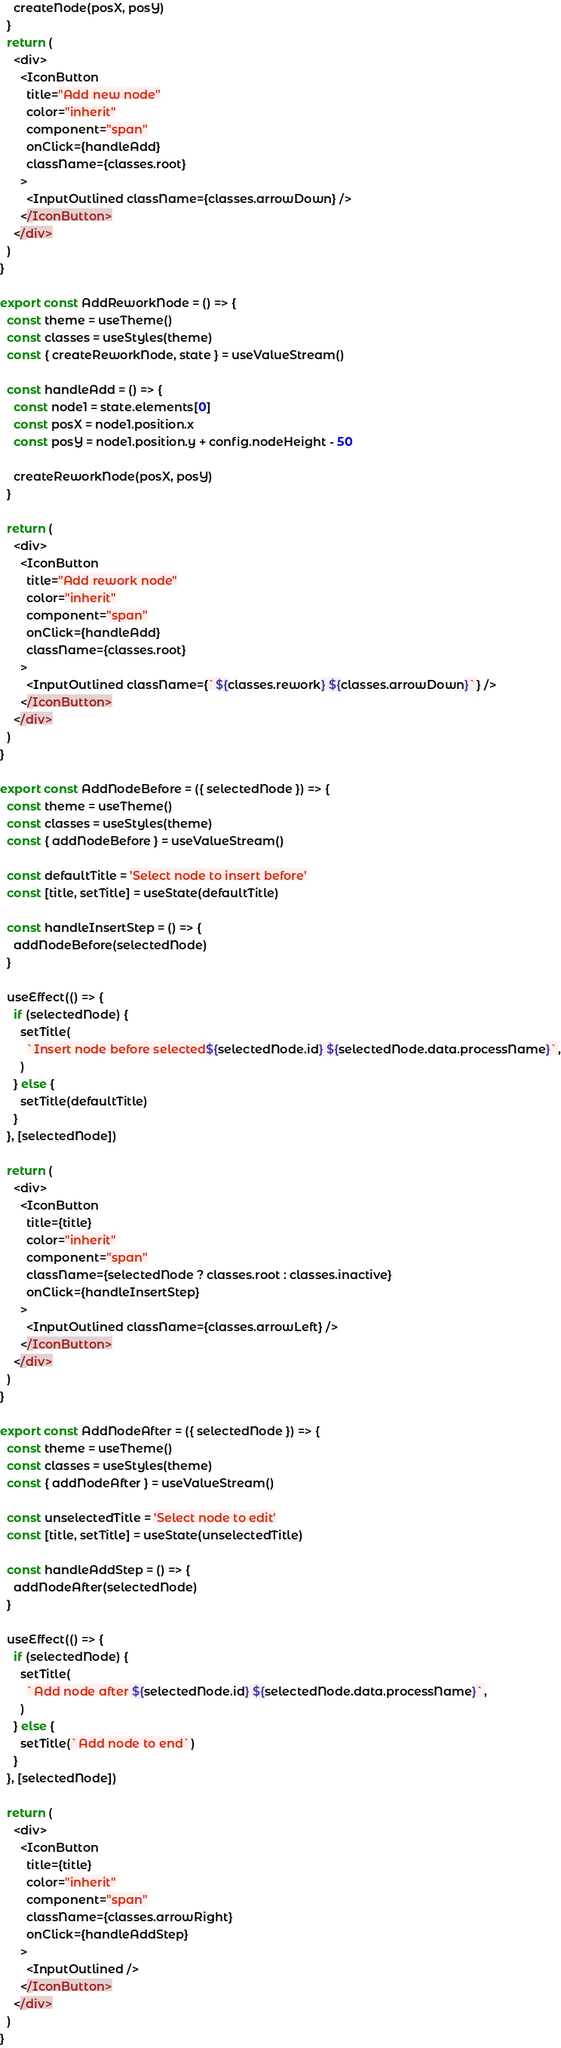<code> <loc_0><loc_0><loc_500><loc_500><_JavaScript_>    createNode(posX, posY)
  }
  return (
    <div>
      <IconButton
        title="Add new node"
        color="inherit"
        component="span"
        onClick={handleAdd}
        className={classes.root}
      >
        <InputOutlined className={classes.arrowDown} />
      </IconButton>
    </div>
  )
}

export const AddReworkNode = () => {
  const theme = useTheme()
  const classes = useStyles(theme)
  const { createReworkNode, state } = useValueStream()

  const handleAdd = () => {
    const node1 = state.elements[0]
    const posX = node1.position.x
    const posY = node1.position.y + config.nodeHeight - 50

    createReworkNode(posX, posY)
  }

  return (
    <div>
      <IconButton
        title="Add rework node"
        color="inherit"
        component="span"
        onClick={handleAdd}
        className={classes.root}
      >
        <InputOutlined className={`${classes.rework} ${classes.arrowDown}`} />
      </IconButton>
    </div>
  )
}

export const AddNodeBefore = ({ selectedNode }) => {
  const theme = useTheme()
  const classes = useStyles(theme)
  const { addNodeBefore } = useValueStream()

  const defaultTitle = 'Select node to insert before'
  const [title, setTitle] = useState(defaultTitle)

  const handleInsertStep = () => {
    addNodeBefore(selectedNode)
  }

  useEffect(() => {
    if (selectedNode) {
      setTitle(
        `Insert node before selected${selectedNode.id} ${selectedNode.data.processName}`,
      )
    } else {
      setTitle(defaultTitle)
    }
  }, [selectedNode])

  return (
    <div>
      <IconButton
        title={title}
        color="inherit"
        component="span"
        className={selectedNode ? classes.root : classes.inactive}
        onClick={handleInsertStep}
      >
        <InputOutlined className={classes.arrowLeft} />
      </IconButton>
    </div>
  )
}

export const AddNodeAfter = ({ selectedNode }) => {
  const theme = useTheme()
  const classes = useStyles(theme)
  const { addNodeAfter } = useValueStream()

  const unselectedTitle = 'Select node to edit'
  const [title, setTitle] = useState(unselectedTitle)

  const handleAddStep = () => {
    addNodeAfter(selectedNode)
  }

  useEffect(() => {
    if (selectedNode) {
      setTitle(
        `Add node after ${selectedNode.id} ${selectedNode.data.processName}`,
      )
    } else {
      setTitle(`Add node to end`)
    }
  }, [selectedNode])

  return (
    <div>
      <IconButton
        title={title}
        color="inherit"
        component="span"
        className={classes.arrowRight}
        onClick={handleAddStep}
      >
        <InputOutlined />
      </IconButton>
    </div>
  )
}
</code> 